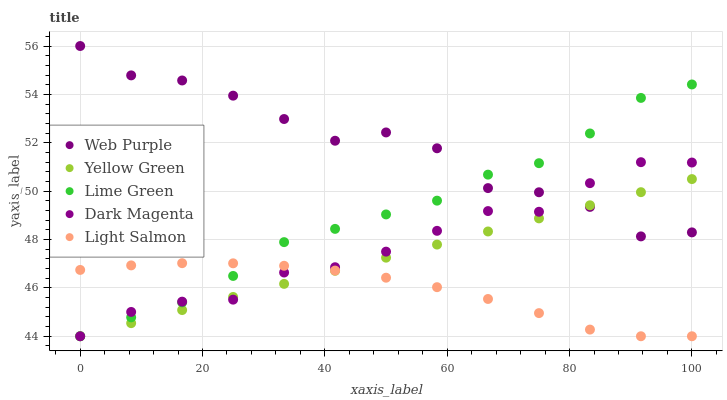Does Light Salmon have the minimum area under the curve?
Answer yes or no. Yes. Does Web Purple have the maximum area under the curve?
Answer yes or no. Yes. Does Lime Green have the minimum area under the curve?
Answer yes or no. No. Does Lime Green have the maximum area under the curve?
Answer yes or no. No. Is Yellow Green the smoothest?
Answer yes or no. Yes. Is Web Purple the roughest?
Answer yes or no. Yes. Is Lime Green the smoothest?
Answer yes or no. No. Is Lime Green the roughest?
Answer yes or no. No. Does Lime Green have the lowest value?
Answer yes or no. Yes. Does Web Purple have the highest value?
Answer yes or no. Yes. Does Lime Green have the highest value?
Answer yes or no. No. Is Light Salmon less than Web Purple?
Answer yes or no. Yes. Is Web Purple greater than Light Salmon?
Answer yes or no. Yes. Does Yellow Green intersect Web Purple?
Answer yes or no. Yes. Is Yellow Green less than Web Purple?
Answer yes or no. No. Is Yellow Green greater than Web Purple?
Answer yes or no. No. Does Light Salmon intersect Web Purple?
Answer yes or no. No. 